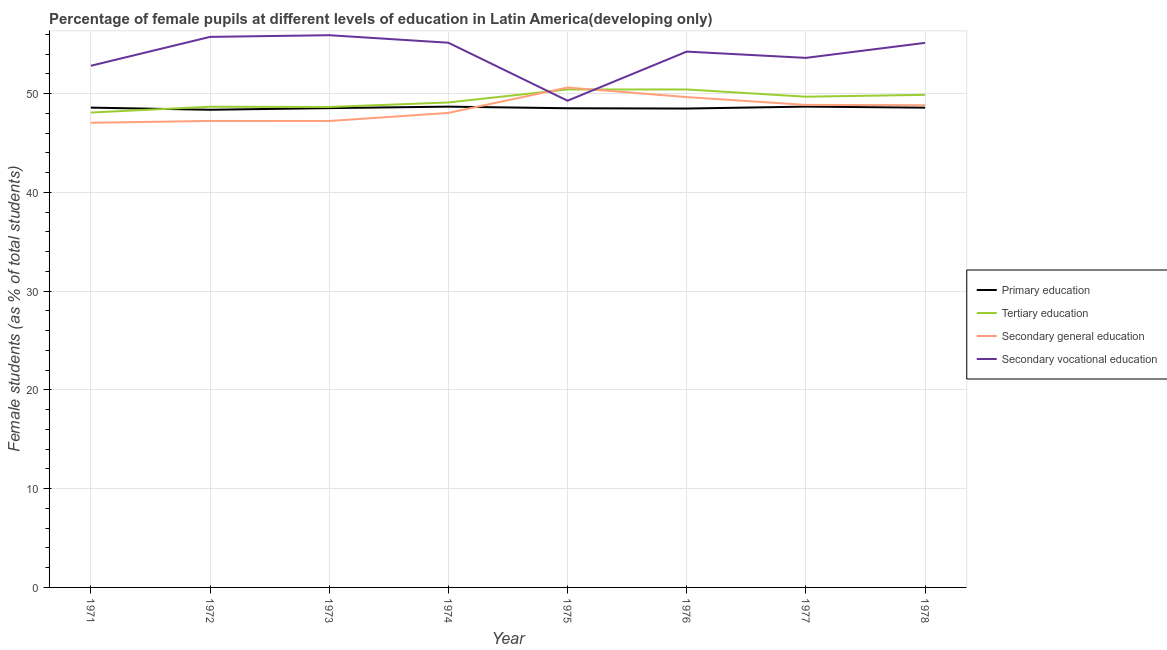Does the line corresponding to percentage of female students in secondary vocational education intersect with the line corresponding to percentage of female students in primary education?
Provide a short and direct response. No. What is the percentage of female students in secondary education in 1972?
Ensure brevity in your answer.  47.24. Across all years, what is the maximum percentage of female students in secondary vocational education?
Ensure brevity in your answer.  55.92. Across all years, what is the minimum percentage of female students in tertiary education?
Give a very brief answer. 48.09. In which year was the percentage of female students in primary education maximum?
Ensure brevity in your answer.  1977. What is the total percentage of female students in secondary education in the graph?
Keep it short and to the point. 387.55. What is the difference between the percentage of female students in secondary vocational education in 1974 and that in 1975?
Your answer should be compact. 5.87. What is the difference between the percentage of female students in secondary education in 1975 and the percentage of female students in primary education in 1973?
Keep it short and to the point. 2.08. What is the average percentage of female students in secondary vocational education per year?
Your response must be concise. 54. In the year 1977, what is the difference between the percentage of female students in tertiary education and percentage of female students in secondary education?
Your answer should be compact. 0.83. What is the ratio of the percentage of female students in secondary education in 1972 to that in 1977?
Offer a terse response. 0.97. Is the percentage of female students in primary education in 1973 less than that in 1974?
Offer a very short reply. Yes. What is the difference between the highest and the second highest percentage of female students in secondary vocational education?
Offer a very short reply. 0.17. What is the difference between the highest and the lowest percentage of female students in secondary vocational education?
Ensure brevity in your answer.  6.63. In how many years, is the percentage of female students in tertiary education greater than the average percentage of female students in tertiary education taken over all years?
Your response must be concise. 4. Is it the case that in every year, the sum of the percentage of female students in tertiary education and percentage of female students in secondary education is greater than the sum of percentage of female students in primary education and percentage of female students in secondary vocational education?
Your answer should be very brief. No. Is it the case that in every year, the sum of the percentage of female students in primary education and percentage of female students in tertiary education is greater than the percentage of female students in secondary education?
Provide a succinct answer. Yes. Is the percentage of female students in secondary education strictly greater than the percentage of female students in tertiary education over the years?
Offer a terse response. No. Is the percentage of female students in secondary education strictly less than the percentage of female students in tertiary education over the years?
Make the answer very short. No. How many lines are there?
Make the answer very short. 4. What is the difference between two consecutive major ticks on the Y-axis?
Provide a succinct answer. 10. Are the values on the major ticks of Y-axis written in scientific E-notation?
Your answer should be very brief. No. Does the graph contain any zero values?
Your answer should be compact. No. How many legend labels are there?
Keep it short and to the point. 4. What is the title of the graph?
Provide a short and direct response. Percentage of female pupils at different levels of education in Latin America(developing only). Does "European Union" appear as one of the legend labels in the graph?
Make the answer very short. No. What is the label or title of the Y-axis?
Offer a very short reply. Female students (as % of total students). What is the Female students (as % of total students) of Primary education in 1971?
Keep it short and to the point. 48.59. What is the Female students (as % of total students) in Tertiary education in 1971?
Provide a succinct answer. 48.09. What is the Female students (as % of total students) in Secondary general education in 1971?
Offer a very short reply. 47.05. What is the Female students (as % of total students) in Secondary vocational education in 1971?
Your answer should be compact. 52.83. What is the Female students (as % of total students) in Primary education in 1972?
Offer a very short reply. 48.37. What is the Female students (as % of total students) of Tertiary education in 1972?
Provide a short and direct response. 48.68. What is the Female students (as % of total students) in Secondary general education in 1972?
Give a very brief answer. 47.24. What is the Female students (as % of total students) in Secondary vocational education in 1972?
Your answer should be very brief. 55.75. What is the Female students (as % of total students) of Primary education in 1973?
Make the answer very short. 48.54. What is the Female students (as % of total students) of Tertiary education in 1973?
Make the answer very short. 48.65. What is the Female students (as % of total students) of Secondary general education in 1973?
Give a very brief answer. 47.23. What is the Female students (as % of total students) in Secondary vocational education in 1973?
Provide a short and direct response. 55.92. What is the Female students (as % of total students) in Primary education in 1974?
Offer a terse response. 48.69. What is the Female students (as % of total students) in Tertiary education in 1974?
Keep it short and to the point. 49.11. What is the Female students (as % of total students) of Secondary general education in 1974?
Your answer should be very brief. 48.05. What is the Female students (as % of total students) of Secondary vocational education in 1974?
Provide a succinct answer. 55.16. What is the Female students (as % of total students) in Primary education in 1975?
Provide a succinct answer. 48.52. What is the Female students (as % of total students) of Tertiary education in 1975?
Provide a short and direct response. 50.43. What is the Female students (as % of total students) in Secondary general education in 1975?
Your answer should be compact. 50.62. What is the Female students (as % of total students) in Secondary vocational education in 1975?
Offer a very short reply. 49.29. What is the Female students (as % of total students) of Primary education in 1976?
Your answer should be very brief. 48.49. What is the Female students (as % of total students) in Tertiary education in 1976?
Provide a succinct answer. 50.43. What is the Female students (as % of total students) in Secondary general education in 1976?
Keep it short and to the point. 49.66. What is the Female students (as % of total students) of Secondary vocational education in 1976?
Give a very brief answer. 54.26. What is the Female students (as % of total students) of Primary education in 1977?
Ensure brevity in your answer.  48.69. What is the Female students (as % of total students) in Tertiary education in 1977?
Offer a terse response. 49.69. What is the Female students (as % of total students) in Secondary general education in 1977?
Provide a succinct answer. 48.86. What is the Female students (as % of total students) of Secondary vocational education in 1977?
Give a very brief answer. 53.63. What is the Female students (as % of total students) of Primary education in 1978?
Provide a succinct answer. 48.59. What is the Female students (as % of total students) of Tertiary education in 1978?
Your answer should be compact. 49.88. What is the Female students (as % of total students) in Secondary general education in 1978?
Offer a terse response. 48.83. What is the Female students (as % of total students) of Secondary vocational education in 1978?
Offer a very short reply. 55.15. Across all years, what is the maximum Female students (as % of total students) of Primary education?
Your response must be concise. 48.69. Across all years, what is the maximum Female students (as % of total students) in Tertiary education?
Give a very brief answer. 50.43. Across all years, what is the maximum Female students (as % of total students) of Secondary general education?
Keep it short and to the point. 50.62. Across all years, what is the maximum Female students (as % of total students) of Secondary vocational education?
Give a very brief answer. 55.92. Across all years, what is the minimum Female students (as % of total students) in Primary education?
Keep it short and to the point. 48.37. Across all years, what is the minimum Female students (as % of total students) of Tertiary education?
Make the answer very short. 48.09. Across all years, what is the minimum Female students (as % of total students) of Secondary general education?
Your response must be concise. 47.05. Across all years, what is the minimum Female students (as % of total students) in Secondary vocational education?
Your answer should be very brief. 49.29. What is the total Female students (as % of total students) in Primary education in the graph?
Keep it short and to the point. 388.48. What is the total Female students (as % of total students) in Tertiary education in the graph?
Your response must be concise. 394.96. What is the total Female students (as % of total students) in Secondary general education in the graph?
Keep it short and to the point. 387.55. What is the total Female students (as % of total students) of Secondary vocational education in the graph?
Offer a terse response. 431.98. What is the difference between the Female students (as % of total students) in Primary education in 1971 and that in 1972?
Your answer should be compact. 0.22. What is the difference between the Female students (as % of total students) of Tertiary education in 1971 and that in 1972?
Offer a terse response. -0.59. What is the difference between the Female students (as % of total students) of Secondary general education in 1971 and that in 1972?
Make the answer very short. -0.19. What is the difference between the Female students (as % of total students) in Secondary vocational education in 1971 and that in 1972?
Make the answer very short. -2.93. What is the difference between the Female students (as % of total students) in Primary education in 1971 and that in 1973?
Provide a succinct answer. 0.05. What is the difference between the Female students (as % of total students) of Tertiary education in 1971 and that in 1973?
Your response must be concise. -0.56. What is the difference between the Female students (as % of total students) of Secondary general education in 1971 and that in 1973?
Give a very brief answer. -0.18. What is the difference between the Female students (as % of total students) of Secondary vocational education in 1971 and that in 1973?
Offer a terse response. -3.1. What is the difference between the Female students (as % of total students) of Primary education in 1971 and that in 1974?
Make the answer very short. -0.1. What is the difference between the Female students (as % of total students) of Tertiary education in 1971 and that in 1974?
Keep it short and to the point. -1.02. What is the difference between the Female students (as % of total students) of Secondary general education in 1971 and that in 1974?
Your answer should be compact. -1. What is the difference between the Female students (as % of total students) of Secondary vocational education in 1971 and that in 1974?
Provide a succinct answer. -2.33. What is the difference between the Female students (as % of total students) of Primary education in 1971 and that in 1975?
Ensure brevity in your answer.  0.06. What is the difference between the Female students (as % of total students) of Tertiary education in 1971 and that in 1975?
Keep it short and to the point. -2.34. What is the difference between the Female students (as % of total students) of Secondary general education in 1971 and that in 1975?
Your answer should be compact. -3.57. What is the difference between the Female students (as % of total students) of Secondary vocational education in 1971 and that in 1975?
Keep it short and to the point. 3.54. What is the difference between the Female students (as % of total students) in Primary education in 1971 and that in 1976?
Keep it short and to the point. 0.09. What is the difference between the Female students (as % of total students) of Tertiary education in 1971 and that in 1976?
Your answer should be very brief. -2.34. What is the difference between the Female students (as % of total students) in Secondary general education in 1971 and that in 1976?
Offer a terse response. -2.6. What is the difference between the Female students (as % of total students) of Secondary vocational education in 1971 and that in 1976?
Provide a short and direct response. -1.43. What is the difference between the Female students (as % of total students) of Primary education in 1971 and that in 1977?
Provide a short and direct response. -0.1. What is the difference between the Female students (as % of total students) in Tertiary education in 1971 and that in 1977?
Make the answer very short. -1.6. What is the difference between the Female students (as % of total students) of Secondary general education in 1971 and that in 1977?
Make the answer very short. -1.81. What is the difference between the Female students (as % of total students) of Secondary vocational education in 1971 and that in 1977?
Offer a very short reply. -0.8. What is the difference between the Female students (as % of total students) in Primary education in 1971 and that in 1978?
Your answer should be very brief. 0. What is the difference between the Female students (as % of total students) in Tertiary education in 1971 and that in 1978?
Ensure brevity in your answer.  -1.8. What is the difference between the Female students (as % of total students) of Secondary general education in 1971 and that in 1978?
Provide a succinct answer. -1.78. What is the difference between the Female students (as % of total students) in Secondary vocational education in 1971 and that in 1978?
Your response must be concise. -2.32. What is the difference between the Female students (as % of total students) in Primary education in 1972 and that in 1973?
Offer a very short reply. -0.17. What is the difference between the Female students (as % of total students) of Tertiary education in 1972 and that in 1973?
Offer a terse response. 0.03. What is the difference between the Female students (as % of total students) of Secondary general education in 1972 and that in 1973?
Give a very brief answer. 0.01. What is the difference between the Female students (as % of total students) of Secondary vocational education in 1972 and that in 1973?
Provide a short and direct response. -0.17. What is the difference between the Female students (as % of total students) of Primary education in 1972 and that in 1974?
Give a very brief answer. -0.32. What is the difference between the Female students (as % of total students) in Tertiary education in 1972 and that in 1974?
Ensure brevity in your answer.  -0.43. What is the difference between the Female students (as % of total students) in Secondary general education in 1972 and that in 1974?
Keep it short and to the point. -0.81. What is the difference between the Female students (as % of total students) of Secondary vocational education in 1972 and that in 1974?
Give a very brief answer. 0.59. What is the difference between the Female students (as % of total students) of Primary education in 1972 and that in 1975?
Keep it short and to the point. -0.15. What is the difference between the Female students (as % of total students) in Tertiary education in 1972 and that in 1975?
Make the answer very short. -1.75. What is the difference between the Female students (as % of total students) in Secondary general education in 1972 and that in 1975?
Offer a very short reply. -3.38. What is the difference between the Female students (as % of total students) of Secondary vocational education in 1972 and that in 1975?
Your answer should be very brief. 6.46. What is the difference between the Female students (as % of total students) in Primary education in 1972 and that in 1976?
Ensure brevity in your answer.  -0.12. What is the difference between the Female students (as % of total students) in Tertiary education in 1972 and that in 1976?
Provide a succinct answer. -1.75. What is the difference between the Female students (as % of total students) of Secondary general education in 1972 and that in 1976?
Your answer should be compact. -2.42. What is the difference between the Female students (as % of total students) in Secondary vocational education in 1972 and that in 1976?
Your answer should be compact. 1.49. What is the difference between the Female students (as % of total students) in Primary education in 1972 and that in 1977?
Ensure brevity in your answer.  -0.32. What is the difference between the Female students (as % of total students) of Tertiary education in 1972 and that in 1977?
Offer a terse response. -1.01. What is the difference between the Female students (as % of total students) in Secondary general education in 1972 and that in 1977?
Keep it short and to the point. -1.62. What is the difference between the Female students (as % of total students) in Secondary vocational education in 1972 and that in 1977?
Your response must be concise. 2.12. What is the difference between the Female students (as % of total students) of Primary education in 1972 and that in 1978?
Your answer should be compact. -0.21. What is the difference between the Female students (as % of total students) in Tertiary education in 1972 and that in 1978?
Give a very brief answer. -1.21. What is the difference between the Female students (as % of total students) of Secondary general education in 1972 and that in 1978?
Your answer should be compact. -1.59. What is the difference between the Female students (as % of total students) of Secondary vocational education in 1972 and that in 1978?
Your response must be concise. 0.61. What is the difference between the Female students (as % of total students) in Primary education in 1973 and that in 1974?
Offer a very short reply. -0.15. What is the difference between the Female students (as % of total students) of Tertiary education in 1973 and that in 1974?
Offer a very short reply. -0.46. What is the difference between the Female students (as % of total students) in Secondary general education in 1973 and that in 1974?
Your answer should be very brief. -0.82. What is the difference between the Female students (as % of total students) of Secondary vocational education in 1973 and that in 1974?
Make the answer very short. 0.76. What is the difference between the Female students (as % of total students) in Primary education in 1973 and that in 1975?
Your response must be concise. 0.01. What is the difference between the Female students (as % of total students) in Tertiary education in 1973 and that in 1975?
Ensure brevity in your answer.  -1.78. What is the difference between the Female students (as % of total students) of Secondary general education in 1973 and that in 1975?
Make the answer very short. -3.39. What is the difference between the Female students (as % of total students) of Secondary vocational education in 1973 and that in 1975?
Give a very brief answer. 6.63. What is the difference between the Female students (as % of total students) of Primary education in 1973 and that in 1976?
Your answer should be compact. 0.04. What is the difference between the Female students (as % of total students) in Tertiary education in 1973 and that in 1976?
Your answer should be compact. -1.78. What is the difference between the Female students (as % of total students) of Secondary general education in 1973 and that in 1976?
Offer a very short reply. -2.42. What is the difference between the Female students (as % of total students) in Secondary vocational education in 1973 and that in 1976?
Ensure brevity in your answer.  1.66. What is the difference between the Female students (as % of total students) in Primary education in 1973 and that in 1977?
Give a very brief answer. -0.15. What is the difference between the Female students (as % of total students) in Tertiary education in 1973 and that in 1977?
Keep it short and to the point. -1.04. What is the difference between the Female students (as % of total students) in Secondary general education in 1973 and that in 1977?
Keep it short and to the point. -1.63. What is the difference between the Female students (as % of total students) in Secondary vocational education in 1973 and that in 1977?
Provide a short and direct response. 2.3. What is the difference between the Female students (as % of total students) in Primary education in 1973 and that in 1978?
Keep it short and to the point. -0.05. What is the difference between the Female students (as % of total students) in Tertiary education in 1973 and that in 1978?
Your response must be concise. -1.23. What is the difference between the Female students (as % of total students) in Secondary general education in 1973 and that in 1978?
Offer a very short reply. -1.59. What is the difference between the Female students (as % of total students) in Secondary vocational education in 1973 and that in 1978?
Ensure brevity in your answer.  0.78. What is the difference between the Female students (as % of total students) of Primary education in 1974 and that in 1975?
Your response must be concise. 0.16. What is the difference between the Female students (as % of total students) of Tertiary education in 1974 and that in 1975?
Your answer should be very brief. -1.32. What is the difference between the Female students (as % of total students) of Secondary general education in 1974 and that in 1975?
Your answer should be very brief. -2.57. What is the difference between the Female students (as % of total students) in Secondary vocational education in 1974 and that in 1975?
Make the answer very short. 5.87. What is the difference between the Female students (as % of total students) of Primary education in 1974 and that in 1976?
Make the answer very short. 0.19. What is the difference between the Female students (as % of total students) in Tertiary education in 1974 and that in 1976?
Offer a terse response. -1.32. What is the difference between the Female students (as % of total students) of Secondary general education in 1974 and that in 1976?
Keep it short and to the point. -1.6. What is the difference between the Female students (as % of total students) in Secondary vocational education in 1974 and that in 1976?
Make the answer very short. 0.9. What is the difference between the Female students (as % of total students) in Primary education in 1974 and that in 1977?
Your answer should be compact. -0. What is the difference between the Female students (as % of total students) in Tertiary education in 1974 and that in 1977?
Make the answer very short. -0.58. What is the difference between the Female students (as % of total students) in Secondary general education in 1974 and that in 1977?
Offer a very short reply. -0.81. What is the difference between the Female students (as % of total students) of Secondary vocational education in 1974 and that in 1977?
Offer a very short reply. 1.53. What is the difference between the Female students (as % of total students) of Primary education in 1974 and that in 1978?
Ensure brevity in your answer.  0.1. What is the difference between the Female students (as % of total students) of Tertiary education in 1974 and that in 1978?
Offer a very short reply. -0.77. What is the difference between the Female students (as % of total students) in Secondary general education in 1974 and that in 1978?
Provide a succinct answer. -0.78. What is the difference between the Female students (as % of total students) in Secondary vocational education in 1974 and that in 1978?
Provide a short and direct response. 0.01. What is the difference between the Female students (as % of total students) of Primary education in 1975 and that in 1976?
Your response must be concise. 0.03. What is the difference between the Female students (as % of total students) of Tertiary education in 1975 and that in 1976?
Your response must be concise. 0. What is the difference between the Female students (as % of total students) of Secondary general education in 1975 and that in 1976?
Keep it short and to the point. 0.97. What is the difference between the Female students (as % of total students) in Secondary vocational education in 1975 and that in 1976?
Provide a short and direct response. -4.97. What is the difference between the Female students (as % of total students) of Primary education in 1975 and that in 1977?
Your response must be concise. -0.17. What is the difference between the Female students (as % of total students) in Tertiary education in 1975 and that in 1977?
Your response must be concise. 0.73. What is the difference between the Female students (as % of total students) in Secondary general education in 1975 and that in 1977?
Make the answer very short. 1.76. What is the difference between the Female students (as % of total students) in Secondary vocational education in 1975 and that in 1977?
Offer a terse response. -4.34. What is the difference between the Female students (as % of total students) of Primary education in 1975 and that in 1978?
Provide a short and direct response. -0.06. What is the difference between the Female students (as % of total students) of Tertiary education in 1975 and that in 1978?
Make the answer very short. 0.54. What is the difference between the Female students (as % of total students) in Secondary general education in 1975 and that in 1978?
Ensure brevity in your answer.  1.79. What is the difference between the Female students (as % of total students) in Secondary vocational education in 1975 and that in 1978?
Offer a terse response. -5.86. What is the difference between the Female students (as % of total students) of Primary education in 1976 and that in 1977?
Offer a very short reply. -0.2. What is the difference between the Female students (as % of total students) in Tertiary education in 1976 and that in 1977?
Offer a terse response. 0.73. What is the difference between the Female students (as % of total students) in Secondary general education in 1976 and that in 1977?
Provide a succinct answer. 0.79. What is the difference between the Female students (as % of total students) of Secondary vocational education in 1976 and that in 1977?
Ensure brevity in your answer.  0.63. What is the difference between the Female students (as % of total students) of Primary education in 1976 and that in 1978?
Provide a short and direct response. -0.09. What is the difference between the Female students (as % of total students) in Tertiary education in 1976 and that in 1978?
Your response must be concise. 0.54. What is the difference between the Female students (as % of total students) in Secondary general education in 1976 and that in 1978?
Your response must be concise. 0.83. What is the difference between the Female students (as % of total students) of Secondary vocational education in 1976 and that in 1978?
Your answer should be compact. -0.89. What is the difference between the Female students (as % of total students) of Primary education in 1977 and that in 1978?
Your answer should be compact. 0.1. What is the difference between the Female students (as % of total students) in Tertiary education in 1977 and that in 1978?
Provide a short and direct response. -0.19. What is the difference between the Female students (as % of total students) of Secondary general education in 1977 and that in 1978?
Your response must be concise. 0.04. What is the difference between the Female students (as % of total students) of Secondary vocational education in 1977 and that in 1978?
Provide a short and direct response. -1.52. What is the difference between the Female students (as % of total students) of Primary education in 1971 and the Female students (as % of total students) of Tertiary education in 1972?
Make the answer very short. -0.09. What is the difference between the Female students (as % of total students) in Primary education in 1971 and the Female students (as % of total students) in Secondary general education in 1972?
Offer a very short reply. 1.35. What is the difference between the Female students (as % of total students) in Primary education in 1971 and the Female students (as % of total students) in Secondary vocational education in 1972?
Provide a short and direct response. -7.16. What is the difference between the Female students (as % of total students) in Tertiary education in 1971 and the Female students (as % of total students) in Secondary general education in 1972?
Provide a succinct answer. 0.85. What is the difference between the Female students (as % of total students) of Tertiary education in 1971 and the Female students (as % of total students) of Secondary vocational education in 1972?
Offer a very short reply. -7.66. What is the difference between the Female students (as % of total students) of Secondary general education in 1971 and the Female students (as % of total students) of Secondary vocational education in 1972?
Keep it short and to the point. -8.7. What is the difference between the Female students (as % of total students) in Primary education in 1971 and the Female students (as % of total students) in Tertiary education in 1973?
Keep it short and to the point. -0.06. What is the difference between the Female students (as % of total students) of Primary education in 1971 and the Female students (as % of total students) of Secondary general education in 1973?
Give a very brief answer. 1.35. What is the difference between the Female students (as % of total students) in Primary education in 1971 and the Female students (as % of total students) in Secondary vocational education in 1973?
Your response must be concise. -7.33. What is the difference between the Female students (as % of total students) of Tertiary education in 1971 and the Female students (as % of total students) of Secondary general education in 1973?
Your answer should be compact. 0.86. What is the difference between the Female students (as % of total students) in Tertiary education in 1971 and the Female students (as % of total students) in Secondary vocational education in 1973?
Give a very brief answer. -7.83. What is the difference between the Female students (as % of total students) of Secondary general education in 1971 and the Female students (as % of total students) of Secondary vocational education in 1973?
Make the answer very short. -8.87. What is the difference between the Female students (as % of total students) of Primary education in 1971 and the Female students (as % of total students) of Tertiary education in 1974?
Ensure brevity in your answer.  -0.52. What is the difference between the Female students (as % of total students) in Primary education in 1971 and the Female students (as % of total students) in Secondary general education in 1974?
Your answer should be very brief. 0.54. What is the difference between the Female students (as % of total students) of Primary education in 1971 and the Female students (as % of total students) of Secondary vocational education in 1974?
Your response must be concise. -6.57. What is the difference between the Female students (as % of total students) of Tertiary education in 1971 and the Female students (as % of total students) of Secondary general education in 1974?
Give a very brief answer. 0.04. What is the difference between the Female students (as % of total students) of Tertiary education in 1971 and the Female students (as % of total students) of Secondary vocational education in 1974?
Provide a short and direct response. -7.07. What is the difference between the Female students (as % of total students) in Secondary general education in 1971 and the Female students (as % of total students) in Secondary vocational education in 1974?
Your response must be concise. -8.11. What is the difference between the Female students (as % of total students) in Primary education in 1971 and the Female students (as % of total students) in Tertiary education in 1975?
Your answer should be compact. -1.84. What is the difference between the Female students (as % of total students) in Primary education in 1971 and the Female students (as % of total students) in Secondary general education in 1975?
Provide a succinct answer. -2.03. What is the difference between the Female students (as % of total students) of Primary education in 1971 and the Female students (as % of total students) of Secondary vocational education in 1975?
Your answer should be very brief. -0.7. What is the difference between the Female students (as % of total students) of Tertiary education in 1971 and the Female students (as % of total students) of Secondary general education in 1975?
Provide a succinct answer. -2.53. What is the difference between the Female students (as % of total students) in Tertiary education in 1971 and the Female students (as % of total students) in Secondary vocational education in 1975?
Give a very brief answer. -1.2. What is the difference between the Female students (as % of total students) in Secondary general education in 1971 and the Female students (as % of total students) in Secondary vocational education in 1975?
Offer a terse response. -2.24. What is the difference between the Female students (as % of total students) in Primary education in 1971 and the Female students (as % of total students) in Tertiary education in 1976?
Provide a short and direct response. -1.84. What is the difference between the Female students (as % of total students) of Primary education in 1971 and the Female students (as % of total students) of Secondary general education in 1976?
Your response must be concise. -1.07. What is the difference between the Female students (as % of total students) of Primary education in 1971 and the Female students (as % of total students) of Secondary vocational education in 1976?
Your answer should be compact. -5.67. What is the difference between the Female students (as % of total students) of Tertiary education in 1971 and the Female students (as % of total students) of Secondary general education in 1976?
Give a very brief answer. -1.57. What is the difference between the Female students (as % of total students) in Tertiary education in 1971 and the Female students (as % of total students) in Secondary vocational education in 1976?
Give a very brief answer. -6.17. What is the difference between the Female students (as % of total students) in Secondary general education in 1971 and the Female students (as % of total students) in Secondary vocational education in 1976?
Make the answer very short. -7.21. What is the difference between the Female students (as % of total students) in Primary education in 1971 and the Female students (as % of total students) in Tertiary education in 1977?
Keep it short and to the point. -1.11. What is the difference between the Female students (as % of total students) in Primary education in 1971 and the Female students (as % of total students) in Secondary general education in 1977?
Provide a short and direct response. -0.28. What is the difference between the Female students (as % of total students) in Primary education in 1971 and the Female students (as % of total students) in Secondary vocational education in 1977?
Give a very brief answer. -5.04. What is the difference between the Female students (as % of total students) of Tertiary education in 1971 and the Female students (as % of total students) of Secondary general education in 1977?
Make the answer very short. -0.77. What is the difference between the Female students (as % of total students) in Tertiary education in 1971 and the Female students (as % of total students) in Secondary vocational education in 1977?
Offer a terse response. -5.54. What is the difference between the Female students (as % of total students) of Secondary general education in 1971 and the Female students (as % of total students) of Secondary vocational education in 1977?
Your answer should be very brief. -6.57. What is the difference between the Female students (as % of total students) in Primary education in 1971 and the Female students (as % of total students) in Tertiary education in 1978?
Provide a short and direct response. -1.3. What is the difference between the Female students (as % of total students) in Primary education in 1971 and the Female students (as % of total students) in Secondary general education in 1978?
Offer a terse response. -0.24. What is the difference between the Female students (as % of total students) in Primary education in 1971 and the Female students (as % of total students) in Secondary vocational education in 1978?
Your answer should be compact. -6.56. What is the difference between the Female students (as % of total students) of Tertiary education in 1971 and the Female students (as % of total students) of Secondary general education in 1978?
Provide a succinct answer. -0.74. What is the difference between the Female students (as % of total students) in Tertiary education in 1971 and the Female students (as % of total students) in Secondary vocational education in 1978?
Give a very brief answer. -7.06. What is the difference between the Female students (as % of total students) of Secondary general education in 1971 and the Female students (as % of total students) of Secondary vocational education in 1978?
Your answer should be very brief. -8.09. What is the difference between the Female students (as % of total students) in Primary education in 1972 and the Female students (as % of total students) in Tertiary education in 1973?
Ensure brevity in your answer.  -0.28. What is the difference between the Female students (as % of total students) of Primary education in 1972 and the Female students (as % of total students) of Secondary general education in 1973?
Ensure brevity in your answer.  1.14. What is the difference between the Female students (as % of total students) of Primary education in 1972 and the Female students (as % of total students) of Secondary vocational education in 1973?
Make the answer very short. -7.55. What is the difference between the Female students (as % of total students) of Tertiary education in 1972 and the Female students (as % of total students) of Secondary general education in 1973?
Offer a very short reply. 1.45. What is the difference between the Female students (as % of total students) of Tertiary education in 1972 and the Female students (as % of total students) of Secondary vocational education in 1973?
Your answer should be compact. -7.24. What is the difference between the Female students (as % of total students) in Secondary general education in 1972 and the Female students (as % of total students) in Secondary vocational education in 1973?
Your response must be concise. -8.68. What is the difference between the Female students (as % of total students) of Primary education in 1972 and the Female students (as % of total students) of Tertiary education in 1974?
Give a very brief answer. -0.74. What is the difference between the Female students (as % of total students) of Primary education in 1972 and the Female students (as % of total students) of Secondary general education in 1974?
Keep it short and to the point. 0.32. What is the difference between the Female students (as % of total students) in Primary education in 1972 and the Female students (as % of total students) in Secondary vocational education in 1974?
Ensure brevity in your answer.  -6.79. What is the difference between the Female students (as % of total students) in Tertiary education in 1972 and the Female students (as % of total students) in Secondary general education in 1974?
Your answer should be compact. 0.63. What is the difference between the Female students (as % of total students) in Tertiary education in 1972 and the Female students (as % of total students) in Secondary vocational education in 1974?
Provide a short and direct response. -6.48. What is the difference between the Female students (as % of total students) in Secondary general education in 1972 and the Female students (as % of total students) in Secondary vocational education in 1974?
Offer a very short reply. -7.92. What is the difference between the Female students (as % of total students) in Primary education in 1972 and the Female students (as % of total students) in Tertiary education in 1975?
Make the answer very short. -2.06. What is the difference between the Female students (as % of total students) in Primary education in 1972 and the Female students (as % of total students) in Secondary general education in 1975?
Your response must be concise. -2.25. What is the difference between the Female students (as % of total students) in Primary education in 1972 and the Female students (as % of total students) in Secondary vocational education in 1975?
Provide a succinct answer. -0.92. What is the difference between the Female students (as % of total students) in Tertiary education in 1972 and the Female students (as % of total students) in Secondary general education in 1975?
Your answer should be very brief. -1.94. What is the difference between the Female students (as % of total students) in Tertiary education in 1972 and the Female students (as % of total students) in Secondary vocational education in 1975?
Offer a very short reply. -0.61. What is the difference between the Female students (as % of total students) in Secondary general education in 1972 and the Female students (as % of total students) in Secondary vocational education in 1975?
Make the answer very short. -2.05. What is the difference between the Female students (as % of total students) of Primary education in 1972 and the Female students (as % of total students) of Tertiary education in 1976?
Offer a terse response. -2.06. What is the difference between the Female students (as % of total students) of Primary education in 1972 and the Female students (as % of total students) of Secondary general education in 1976?
Your response must be concise. -1.28. What is the difference between the Female students (as % of total students) of Primary education in 1972 and the Female students (as % of total students) of Secondary vocational education in 1976?
Your answer should be very brief. -5.89. What is the difference between the Female students (as % of total students) in Tertiary education in 1972 and the Female students (as % of total students) in Secondary general education in 1976?
Your answer should be very brief. -0.98. What is the difference between the Female students (as % of total students) of Tertiary education in 1972 and the Female students (as % of total students) of Secondary vocational education in 1976?
Provide a short and direct response. -5.58. What is the difference between the Female students (as % of total students) in Secondary general education in 1972 and the Female students (as % of total students) in Secondary vocational education in 1976?
Your answer should be compact. -7.02. What is the difference between the Female students (as % of total students) of Primary education in 1972 and the Female students (as % of total students) of Tertiary education in 1977?
Keep it short and to the point. -1.32. What is the difference between the Female students (as % of total students) in Primary education in 1972 and the Female students (as % of total students) in Secondary general education in 1977?
Provide a succinct answer. -0.49. What is the difference between the Female students (as % of total students) in Primary education in 1972 and the Female students (as % of total students) in Secondary vocational education in 1977?
Keep it short and to the point. -5.26. What is the difference between the Female students (as % of total students) in Tertiary education in 1972 and the Female students (as % of total students) in Secondary general education in 1977?
Your response must be concise. -0.18. What is the difference between the Female students (as % of total students) in Tertiary education in 1972 and the Female students (as % of total students) in Secondary vocational education in 1977?
Ensure brevity in your answer.  -4.95. What is the difference between the Female students (as % of total students) in Secondary general education in 1972 and the Female students (as % of total students) in Secondary vocational education in 1977?
Your answer should be compact. -6.39. What is the difference between the Female students (as % of total students) of Primary education in 1972 and the Female students (as % of total students) of Tertiary education in 1978?
Ensure brevity in your answer.  -1.51. What is the difference between the Female students (as % of total students) in Primary education in 1972 and the Female students (as % of total students) in Secondary general education in 1978?
Ensure brevity in your answer.  -0.46. What is the difference between the Female students (as % of total students) in Primary education in 1972 and the Female students (as % of total students) in Secondary vocational education in 1978?
Your response must be concise. -6.77. What is the difference between the Female students (as % of total students) in Tertiary education in 1972 and the Female students (as % of total students) in Secondary general education in 1978?
Your answer should be compact. -0.15. What is the difference between the Female students (as % of total students) of Tertiary education in 1972 and the Female students (as % of total students) of Secondary vocational education in 1978?
Provide a short and direct response. -6.47. What is the difference between the Female students (as % of total students) in Secondary general education in 1972 and the Female students (as % of total students) in Secondary vocational education in 1978?
Your response must be concise. -7.91. What is the difference between the Female students (as % of total students) in Primary education in 1973 and the Female students (as % of total students) in Tertiary education in 1974?
Offer a terse response. -0.57. What is the difference between the Female students (as % of total students) in Primary education in 1973 and the Female students (as % of total students) in Secondary general education in 1974?
Make the answer very short. 0.49. What is the difference between the Female students (as % of total students) in Primary education in 1973 and the Female students (as % of total students) in Secondary vocational education in 1974?
Offer a terse response. -6.62. What is the difference between the Female students (as % of total students) in Tertiary education in 1973 and the Female students (as % of total students) in Secondary general education in 1974?
Offer a terse response. 0.6. What is the difference between the Female students (as % of total students) of Tertiary education in 1973 and the Female students (as % of total students) of Secondary vocational education in 1974?
Your answer should be very brief. -6.51. What is the difference between the Female students (as % of total students) in Secondary general education in 1973 and the Female students (as % of total students) in Secondary vocational education in 1974?
Offer a terse response. -7.93. What is the difference between the Female students (as % of total students) of Primary education in 1973 and the Female students (as % of total students) of Tertiary education in 1975?
Your answer should be very brief. -1.89. What is the difference between the Female students (as % of total students) of Primary education in 1973 and the Female students (as % of total students) of Secondary general education in 1975?
Offer a terse response. -2.08. What is the difference between the Female students (as % of total students) of Primary education in 1973 and the Female students (as % of total students) of Secondary vocational education in 1975?
Your response must be concise. -0.75. What is the difference between the Female students (as % of total students) in Tertiary education in 1973 and the Female students (as % of total students) in Secondary general education in 1975?
Keep it short and to the point. -1.97. What is the difference between the Female students (as % of total students) in Tertiary education in 1973 and the Female students (as % of total students) in Secondary vocational education in 1975?
Offer a terse response. -0.64. What is the difference between the Female students (as % of total students) in Secondary general education in 1973 and the Female students (as % of total students) in Secondary vocational education in 1975?
Provide a short and direct response. -2.05. What is the difference between the Female students (as % of total students) of Primary education in 1973 and the Female students (as % of total students) of Tertiary education in 1976?
Your answer should be compact. -1.89. What is the difference between the Female students (as % of total students) of Primary education in 1973 and the Female students (as % of total students) of Secondary general education in 1976?
Ensure brevity in your answer.  -1.12. What is the difference between the Female students (as % of total students) of Primary education in 1973 and the Female students (as % of total students) of Secondary vocational education in 1976?
Offer a very short reply. -5.72. What is the difference between the Female students (as % of total students) of Tertiary education in 1973 and the Female students (as % of total students) of Secondary general education in 1976?
Your answer should be very brief. -1. What is the difference between the Female students (as % of total students) in Tertiary education in 1973 and the Female students (as % of total students) in Secondary vocational education in 1976?
Provide a succinct answer. -5.61. What is the difference between the Female students (as % of total students) of Secondary general education in 1973 and the Female students (as % of total students) of Secondary vocational education in 1976?
Give a very brief answer. -7.03. What is the difference between the Female students (as % of total students) in Primary education in 1973 and the Female students (as % of total students) in Tertiary education in 1977?
Keep it short and to the point. -1.16. What is the difference between the Female students (as % of total students) in Primary education in 1973 and the Female students (as % of total students) in Secondary general education in 1977?
Ensure brevity in your answer.  -0.33. What is the difference between the Female students (as % of total students) in Primary education in 1973 and the Female students (as % of total students) in Secondary vocational education in 1977?
Give a very brief answer. -5.09. What is the difference between the Female students (as % of total students) of Tertiary education in 1973 and the Female students (as % of total students) of Secondary general education in 1977?
Ensure brevity in your answer.  -0.21. What is the difference between the Female students (as % of total students) of Tertiary education in 1973 and the Female students (as % of total students) of Secondary vocational education in 1977?
Provide a succinct answer. -4.98. What is the difference between the Female students (as % of total students) of Secondary general education in 1973 and the Female students (as % of total students) of Secondary vocational education in 1977?
Give a very brief answer. -6.39. What is the difference between the Female students (as % of total students) in Primary education in 1973 and the Female students (as % of total students) in Tertiary education in 1978?
Offer a very short reply. -1.35. What is the difference between the Female students (as % of total students) of Primary education in 1973 and the Female students (as % of total students) of Secondary general education in 1978?
Keep it short and to the point. -0.29. What is the difference between the Female students (as % of total students) in Primary education in 1973 and the Female students (as % of total students) in Secondary vocational education in 1978?
Your answer should be very brief. -6.61. What is the difference between the Female students (as % of total students) in Tertiary education in 1973 and the Female students (as % of total students) in Secondary general education in 1978?
Give a very brief answer. -0.18. What is the difference between the Female students (as % of total students) in Tertiary education in 1973 and the Female students (as % of total students) in Secondary vocational education in 1978?
Your response must be concise. -6.5. What is the difference between the Female students (as % of total students) in Secondary general education in 1973 and the Female students (as % of total students) in Secondary vocational education in 1978?
Give a very brief answer. -7.91. What is the difference between the Female students (as % of total students) in Primary education in 1974 and the Female students (as % of total students) in Tertiary education in 1975?
Provide a succinct answer. -1.74. What is the difference between the Female students (as % of total students) of Primary education in 1974 and the Female students (as % of total students) of Secondary general education in 1975?
Keep it short and to the point. -1.94. What is the difference between the Female students (as % of total students) of Primary education in 1974 and the Female students (as % of total students) of Secondary vocational education in 1975?
Ensure brevity in your answer.  -0.6. What is the difference between the Female students (as % of total students) of Tertiary education in 1974 and the Female students (as % of total students) of Secondary general education in 1975?
Ensure brevity in your answer.  -1.51. What is the difference between the Female students (as % of total students) in Tertiary education in 1974 and the Female students (as % of total students) in Secondary vocational education in 1975?
Your response must be concise. -0.18. What is the difference between the Female students (as % of total students) in Secondary general education in 1974 and the Female students (as % of total students) in Secondary vocational education in 1975?
Your answer should be compact. -1.24. What is the difference between the Female students (as % of total students) of Primary education in 1974 and the Female students (as % of total students) of Tertiary education in 1976?
Make the answer very short. -1.74. What is the difference between the Female students (as % of total students) of Primary education in 1974 and the Female students (as % of total students) of Secondary general education in 1976?
Make the answer very short. -0.97. What is the difference between the Female students (as % of total students) of Primary education in 1974 and the Female students (as % of total students) of Secondary vocational education in 1976?
Your response must be concise. -5.57. What is the difference between the Female students (as % of total students) in Tertiary education in 1974 and the Female students (as % of total students) in Secondary general education in 1976?
Provide a succinct answer. -0.55. What is the difference between the Female students (as % of total students) of Tertiary education in 1974 and the Female students (as % of total students) of Secondary vocational education in 1976?
Your answer should be compact. -5.15. What is the difference between the Female students (as % of total students) of Secondary general education in 1974 and the Female students (as % of total students) of Secondary vocational education in 1976?
Provide a short and direct response. -6.21. What is the difference between the Female students (as % of total students) in Primary education in 1974 and the Female students (as % of total students) in Tertiary education in 1977?
Offer a very short reply. -1.01. What is the difference between the Female students (as % of total students) of Primary education in 1974 and the Female students (as % of total students) of Secondary general education in 1977?
Keep it short and to the point. -0.18. What is the difference between the Female students (as % of total students) in Primary education in 1974 and the Female students (as % of total students) in Secondary vocational education in 1977?
Your answer should be very brief. -4.94. What is the difference between the Female students (as % of total students) of Tertiary education in 1974 and the Female students (as % of total students) of Secondary general education in 1977?
Give a very brief answer. 0.25. What is the difference between the Female students (as % of total students) in Tertiary education in 1974 and the Female students (as % of total students) in Secondary vocational education in 1977?
Offer a very short reply. -4.52. What is the difference between the Female students (as % of total students) of Secondary general education in 1974 and the Female students (as % of total students) of Secondary vocational education in 1977?
Make the answer very short. -5.57. What is the difference between the Female students (as % of total students) of Primary education in 1974 and the Female students (as % of total students) of Tertiary education in 1978?
Offer a terse response. -1.2. What is the difference between the Female students (as % of total students) of Primary education in 1974 and the Female students (as % of total students) of Secondary general education in 1978?
Give a very brief answer. -0.14. What is the difference between the Female students (as % of total students) of Primary education in 1974 and the Female students (as % of total students) of Secondary vocational education in 1978?
Offer a very short reply. -6.46. What is the difference between the Female students (as % of total students) in Tertiary education in 1974 and the Female students (as % of total students) in Secondary general education in 1978?
Ensure brevity in your answer.  0.28. What is the difference between the Female students (as % of total students) of Tertiary education in 1974 and the Female students (as % of total students) of Secondary vocational education in 1978?
Ensure brevity in your answer.  -6.04. What is the difference between the Female students (as % of total students) of Secondary general education in 1974 and the Female students (as % of total students) of Secondary vocational education in 1978?
Ensure brevity in your answer.  -7.09. What is the difference between the Female students (as % of total students) of Primary education in 1975 and the Female students (as % of total students) of Tertiary education in 1976?
Your response must be concise. -1.9. What is the difference between the Female students (as % of total students) of Primary education in 1975 and the Female students (as % of total students) of Secondary general education in 1976?
Ensure brevity in your answer.  -1.13. What is the difference between the Female students (as % of total students) in Primary education in 1975 and the Female students (as % of total students) in Secondary vocational education in 1976?
Give a very brief answer. -5.74. What is the difference between the Female students (as % of total students) of Tertiary education in 1975 and the Female students (as % of total students) of Secondary general education in 1976?
Your response must be concise. 0.77. What is the difference between the Female students (as % of total students) of Tertiary education in 1975 and the Female students (as % of total students) of Secondary vocational education in 1976?
Keep it short and to the point. -3.83. What is the difference between the Female students (as % of total students) of Secondary general education in 1975 and the Female students (as % of total students) of Secondary vocational education in 1976?
Ensure brevity in your answer.  -3.64. What is the difference between the Female students (as % of total students) of Primary education in 1975 and the Female students (as % of total students) of Tertiary education in 1977?
Provide a succinct answer. -1.17. What is the difference between the Female students (as % of total students) of Primary education in 1975 and the Female students (as % of total students) of Secondary general education in 1977?
Offer a terse response. -0.34. What is the difference between the Female students (as % of total students) in Primary education in 1975 and the Female students (as % of total students) in Secondary vocational education in 1977?
Offer a very short reply. -5.1. What is the difference between the Female students (as % of total students) of Tertiary education in 1975 and the Female students (as % of total students) of Secondary general education in 1977?
Your answer should be compact. 1.56. What is the difference between the Female students (as % of total students) in Tertiary education in 1975 and the Female students (as % of total students) in Secondary vocational education in 1977?
Offer a very short reply. -3.2. What is the difference between the Female students (as % of total students) of Secondary general education in 1975 and the Female students (as % of total students) of Secondary vocational education in 1977?
Provide a succinct answer. -3. What is the difference between the Female students (as % of total students) in Primary education in 1975 and the Female students (as % of total students) in Tertiary education in 1978?
Make the answer very short. -1.36. What is the difference between the Female students (as % of total students) of Primary education in 1975 and the Female students (as % of total students) of Secondary general education in 1978?
Provide a short and direct response. -0.3. What is the difference between the Female students (as % of total students) in Primary education in 1975 and the Female students (as % of total students) in Secondary vocational education in 1978?
Ensure brevity in your answer.  -6.62. What is the difference between the Female students (as % of total students) in Tertiary education in 1975 and the Female students (as % of total students) in Secondary general education in 1978?
Your answer should be compact. 1.6. What is the difference between the Female students (as % of total students) of Tertiary education in 1975 and the Female students (as % of total students) of Secondary vocational education in 1978?
Offer a very short reply. -4.72. What is the difference between the Female students (as % of total students) in Secondary general education in 1975 and the Female students (as % of total students) in Secondary vocational education in 1978?
Provide a succinct answer. -4.52. What is the difference between the Female students (as % of total students) of Primary education in 1976 and the Female students (as % of total students) of Tertiary education in 1977?
Provide a short and direct response. -1.2. What is the difference between the Female students (as % of total students) of Primary education in 1976 and the Female students (as % of total students) of Secondary general education in 1977?
Keep it short and to the point. -0.37. What is the difference between the Female students (as % of total students) in Primary education in 1976 and the Female students (as % of total students) in Secondary vocational education in 1977?
Ensure brevity in your answer.  -5.13. What is the difference between the Female students (as % of total students) in Tertiary education in 1976 and the Female students (as % of total students) in Secondary general education in 1977?
Provide a succinct answer. 1.56. What is the difference between the Female students (as % of total students) in Tertiary education in 1976 and the Female students (as % of total students) in Secondary vocational education in 1977?
Offer a very short reply. -3.2. What is the difference between the Female students (as % of total students) of Secondary general education in 1976 and the Female students (as % of total students) of Secondary vocational education in 1977?
Give a very brief answer. -3.97. What is the difference between the Female students (as % of total students) of Primary education in 1976 and the Female students (as % of total students) of Tertiary education in 1978?
Keep it short and to the point. -1.39. What is the difference between the Female students (as % of total students) in Primary education in 1976 and the Female students (as % of total students) in Secondary general education in 1978?
Offer a terse response. -0.33. What is the difference between the Female students (as % of total students) of Primary education in 1976 and the Female students (as % of total students) of Secondary vocational education in 1978?
Make the answer very short. -6.65. What is the difference between the Female students (as % of total students) in Tertiary education in 1976 and the Female students (as % of total students) in Secondary general education in 1978?
Your response must be concise. 1.6. What is the difference between the Female students (as % of total students) of Tertiary education in 1976 and the Female students (as % of total students) of Secondary vocational education in 1978?
Make the answer very short. -4.72. What is the difference between the Female students (as % of total students) in Secondary general education in 1976 and the Female students (as % of total students) in Secondary vocational education in 1978?
Give a very brief answer. -5.49. What is the difference between the Female students (as % of total students) of Primary education in 1977 and the Female students (as % of total students) of Tertiary education in 1978?
Make the answer very short. -1.19. What is the difference between the Female students (as % of total students) of Primary education in 1977 and the Female students (as % of total students) of Secondary general education in 1978?
Offer a terse response. -0.14. What is the difference between the Female students (as % of total students) of Primary education in 1977 and the Female students (as % of total students) of Secondary vocational education in 1978?
Give a very brief answer. -6.46. What is the difference between the Female students (as % of total students) in Tertiary education in 1977 and the Female students (as % of total students) in Secondary general education in 1978?
Ensure brevity in your answer.  0.87. What is the difference between the Female students (as % of total students) of Tertiary education in 1977 and the Female students (as % of total students) of Secondary vocational education in 1978?
Your answer should be compact. -5.45. What is the difference between the Female students (as % of total students) in Secondary general education in 1977 and the Female students (as % of total students) in Secondary vocational education in 1978?
Ensure brevity in your answer.  -6.28. What is the average Female students (as % of total students) in Primary education per year?
Ensure brevity in your answer.  48.56. What is the average Female students (as % of total students) in Tertiary education per year?
Offer a terse response. 49.37. What is the average Female students (as % of total students) of Secondary general education per year?
Offer a very short reply. 48.44. What is the average Female students (as % of total students) in Secondary vocational education per year?
Ensure brevity in your answer.  54. In the year 1971, what is the difference between the Female students (as % of total students) of Primary education and Female students (as % of total students) of Tertiary education?
Make the answer very short. 0.5. In the year 1971, what is the difference between the Female students (as % of total students) in Primary education and Female students (as % of total students) in Secondary general education?
Your answer should be compact. 1.54. In the year 1971, what is the difference between the Female students (as % of total students) of Primary education and Female students (as % of total students) of Secondary vocational education?
Provide a succinct answer. -4.24. In the year 1971, what is the difference between the Female students (as % of total students) in Tertiary education and Female students (as % of total students) in Secondary general education?
Ensure brevity in your answer.  1.04. In the year 1971, what is the difference between the Female students (as % of total students) in Tertiary education and Female students (as % of total students) in Secondary vocational education?
Provide a succinct answer. -4.74. In the year 1971, what is the difference between the Female students (as % of total students) of Secondary general education and Female students (as % of total students) of Secondary vocational education?
Keep it short and to the point. -5.77. In the year 1972, what is the difference between the Female students (as % of total students) of Primary education and Female students (as % of total students) of Tertiary education?
Your answer should be very brief. -0.31. In the year 1972, what is the difference between the Female students (as % of total students) in Primary education and Female students (as % of total students) in Secondary general education?
Keep it short and to the point. 1.13. In the year 1972, what is the difference between the Female students (as % of total students) in Primary education and Female students (as % of total students) in Secondary vocational education?
Offer a terse response. -7.38. In the year 1972, what is the difference between the Female students (as % of total students) in Tertiary education and Female students (as % of total students) in Secondary general education?
Offer a terse response. 1.44. In the year 1972, what is the difference between the Female students (as % of total students) in Tertiary education and Female students (as % of total students) in Secondary vocational education?
Offer a very short reply. -7.07. In the year 1972, what is the difference between the Female students (as % of total students) in Secondary general education and Female students (as % of total students) in Secondary vocational education?
Keep it short and to the point. -8.51. In the year 1973, what is the difference between the Female students (as % of total students) in Primary education and Female students (as % of total students) in Tertiary education?
Provide a succinct answer. -0.11. In the year 1973, what is the difference between the Female students (as % of total students) of Primary education and Female students (as % of total students) of Secondary general education?
Provide a short and direct response. 1.3. In the year 1973, what is the difference between the Female students (as % of total students) of Primary education and Female students (as % of total students) of Secondary vocational education?
Make the answer very short. -7.38. In the year 1973, what is the difference between the Female students (as % of total students) of Tertiary education and Female students (as % of total students) of Secondary general education?
Your answer should be very brief. 1.42. In the year 1973, what is the difference between the Female students (as % of total students) of Tertiary education and Female students (as % of total students) of Secondary vocational education?
Your answer should be compact. -7.27. In the year 1973, what is the difference between the Female students (as % of total students) in Secondary general education and Female students (as % of total students) in Secondary vocational education?
Your response must be concise. -8.69. In the year 1974, what is the difference between the Female students (as % of total students) of Primary education and Female students (as % of total students) of Tertiary education?
Keep it short and to the point. -0.42. In the year 1974, what is the difference between the Female students (as % of total students) in Primary education and Female students (as % of total students) in Secondary general education?
Ensure brevity in your answer.  0.63. In the year 1974, what is the difference between the Female students (as % of total students) of Primary education and Female students (as % of total students) of Secondary vocational education?
Give a very brief answer. -6.47. In the year 1974, what is the difference between the Female students (as % of total students) in Tertiary education and Female students (as % of total students) in Secondary general education?
Ensure brevity in your answer.  1.06. In the year 1974, what is the difference between the Female students (as % of total students) of Tertiary education and Female students (as % of total students) of Secondary vocational education?
Offer a terse response. -6.05. In the year 1974, what is the difference between the Female students (as % of total students) in Secondary general education and Female students (as % of total students) in Secondary vocational education?
Offer a terse response. -7.11. In the year 1975, what is the difference between the Female students (as % of total students) in Primary education and Female students (as % of total students) in Tertiary education?
Ensure brevity in your answer.  -1.9. In the year 1975, what is the difference between the Female students (as % of total students) in Primary education and Female students (as % of total students) in Secondary general education?
Your answer should be compact. -2.1. In the year 1975, what is the difference between the Female students (as % of total students) in Primary education and Female students (as % of total students) in Secondary vocational education?
Offer a terse response. -0.76. In the year 1975, what is the difference between the Female students (as % of total students) in Tertiary education and Female students (as % of total students) in Secondary general education?
Provide a short and direct response. -0.2. In the year 1975, what is the difference between the Female students (as % of total students) of Tertiary education and Female students (as % of total students) of Secondary vocational education?
Your answer should be very brief. 1.14. In the year 1975, what is the difference between the Female students (as % of total students) in Secondary general education and Female students (as % of total students) in Secondary vocational education?
Your answer should be very brief. 1.33. In the year 1976, what is the difference between the Female students (as % of total students) in Primary education and Female students (as % of total students) in Tertiary education?
Ensure brevity in your answer.  -1.93. In the year 1976, what is the difference between the Female students (as % of total students) in Primary education and Female students (as % of total students) in Secondary general education?
Keep it short and to the point. -1.16. In the year 1976, what is the difference between the Female students (as % of total students) of Primary education and Female students (as % of total students) of Secondary vocational education?
Keep it short and to the point. -5.77. In the year 1976, what is the difference between the Female students (as % of total students) of Tertiary education and Female students (as % of total students) of Secondary general education?
Keep it short and to the point. 0.77. In the year 1976, what is the difference between the Female students (as % of total students) in Tertiary education and Female students (as % of total students) in Secondary vocational education?
Provide a succinct answer. -3.83. In the year 1976, what is the difference between the Female students (as % of total students) in Secondary general education and Female students (as % of total students) in Secondary vocational education?
Keep it short and to the point. -4.6. In the year 1977, what is the difference between the Female students (as % of total students) of Primary education and Female students (as % of total students) of Tertiary education?
Ensure brevity in your answer.  -1. In the year 1977, what is the difference between the Female students (as % of total students) of Primary education and Female students (as % of total students) of Secondary general education?
Offer a terse response. -0.17. In the year 1977, what is the difference between the Female students (as % of total students) in Primary education and Female students (as % of total students) in Secondary vocational education?
Give a very brief answer. -4.94. In the year 1977, what is the difference between the Female students (as % of total students) in Tertiary education and Female students (as % of total students) in Secondary general education?
Your answer should be compact. 0.83. In the year 1977, what is the difference between the Female students (as % of total students) of Tertiary education and Female students (as % of total students) of Secondary vocational education?
Your answer should be very brief. -3.93. In the year 1977, what is the difference between the Female students (as % of total students) of Secondary general education and Female students (as % of total students) of Secondary vocational education?
Keep it short and to the point. -4.76. In the year 1978, what is the difference between the Female students (as % of total students) in Primary education and Female students (as % of total students) in Tertiary education?
Offer a very short reply. -1.3. In the year 1978, what is the difference between the Female students (as % of total students) of Primary education and Female students (as % of total students) of Secondary general education?
Provide a succinct answer. -0.24. In the year 1978, what is the difference between the Female students (as % of total students) in Primary education and Female students (as % of total students) in Secondary vocational education?
Provide a short and direct response. -6.56. In the year 1978, what is the difference between the Female students (as % of total students) in Tertiary education and Female students (as % of total students) in Secondary general education?
Your response must be concise. 1.06. In the year 1978, what is the difference between the Female students (as % of total students) in Tertiary education and Female students (as % of total students) in Secondary vocational education?
Offer a terse response. -5.26. In the year 1978, what is the difference between the Female students (as % of total students) in Secondary general education and Female students (as % of total students) in Secondary vocational education?
Your answer should be compact. -6.32. What is the ratio of the Female students (as % of total students) of Tertiary education in 1971 to that in 1972?
Provide a succinct answer. 0.99. What is the ratio of the Female students (as % of total students) in Secondary general education in 1971 to that in 1972?
Provide a short and direct response. 1. What is the ratio of the Female students (as % of total students) in Secondary vocational education in 1971 to that in 1972?
Make the answer very short. 0.95. What is the ratio of the Female students (as % of total students) of Primary education in 1971 to that in 1973?
Provide a short and direct response. 1. What is the ratio of the Female students (as % of total students) of Tertiary education in 1971 to that in 1973?
Ensure brevity in your answer.  0.99. What is the ratio of the Female students (as % of total students) in Secondary general education in 1971 to that in 1973?
Your answer should be compact. 1. What is the ratio of the Female students (as % of total students) in Secondary vocational education in 1971 to that in 1973?
Offer a very short reply. 0.94. What is the ratio of the Female students (as % of total students) of Tertiary education in 1971 to that in 1974?
Your answer should be compact. 0.98. What is the ratio of the Female students (as % of total students) of Secondary general education in 1971 to that in 1974?
Provide a succinct answer. 0.98. What is the ratio of the Female students (as % of total students) of Secondary vocational education in 1971 to that in 1974?
Keep it short and to the point. 0.96. What is the ratio of the Female students (as % of total students) of Primary education in 1971 to that in 1975?
Your response must be concise. 1. What is the ratio of the Female students (as % of total students) of Tertiary education in 1971 to that in 1975?
Your answer should be very brief. 0.95. What is the ratio of the Female students (as % of total students) of Secondary general education in 1971 to that in 1975?
Your response must be concise. 0.93. What is the ratio of the Female students (as % of total students) in Secondary vocational education in 1971 to that in 1975?
Provide a succinct answer. 1.07. What is the ratio of the Female students (as % of total students) of Primary education in 1971 to that in 1976?
Your answer should be compact. 1. What is the ratio of the Female students (as % of total students) in Tertiary education in 1971 to that in 1976?
Keep it short and to the point. 0.95. What is the ratio of the Female students (as % of total students) in Secondary general education in 1971 to that in 1976?
Your answer should be very brief. 0.95. What is the ratio of the Female students (as % of total students) of Secondary vocational education in 1971 to that in 1976?
Provide a short and direct response. 0.97. What is the ratio of the Female students (as % of total students) in Primary education in 1971 to that in 1977?
Offer a very short reply. 1. What is the ratio of the Female students (as % of total students) of Tertiary education in 1971 to that in 1977?
Your answer should be compact. 0.97. What is the ratio of the Female students (as % of total students) of Secondary general education in 1971 to that in 1977?
Provide a succinct answer. 0.96. What is the ratio of the Female students (as % of total students) of Secondary vocational education in 1971 to that in 1977?
Your answer should be compact. 0.99. What is the ratio of the Female students (as % of total students) in Primary education in 1971 to that in 1978?
Keep it short and to the point. 1. What is the ratio of the Female students (as % of total students) of Tertiary education in 1971 to that in 1978?
Offer a terse response. 0.96. What is the ratio of the Female students (as % of total students) of Secondary general education in 1971 to that in 1978?
Ensure brevity in your answer.  0.96. What is the ratio of the Female students (as % of total students) in Secondary vocational education in 1971 to that in 1978?
Your response must be concise. 0.96. What is the ratio of the Female students (as % of total students) of Primary education in 1972 to that in 1973?
Your response must be concise. 1. What is the ratio of the Female students (as % of total students) of Tertiary education in 1972 to that in 1973?
Your answer should be compact. 1. What is the ratio of the Female students (as % of total students) of Secondary general education in 1972 to that in 1974?
Provide a short and direct response. 0.98. What is the ratio of the Female students (as % of total students) of Secondary vocational education in 1972 to that in 1974?
Ensure brevity in your answer.  1.01. What is the ratio of the Female students (as % of total students) in Primary education in 1972 to that in 1975?
Keep it short and to the point. 1. What is the ratio of the Female students (as % of total students) in Tertiary education in 1972 to that in 1975?
Your answer should be very brief. 0.97. What is the ratio of the Female students (as % of total students) of Secondary general education in 1972 to that in 1975?
Provide a succinct answer. 0.93. What is the ratio of the Female students (as % of total students) in Secondary vocational education in 1972 to that in 1975?
Offer a very short reply. 1.13. What is the ratio of the Female students (as % of total students) in Primary education in 1972 to that in 1976?
Provide a short and direct response. 1. What is the ratio of the Female students (as % of total students) of Tertiary education in 1972 to that in 1976?
Your answer should be compact. 0.97. What is the ratio of the Female students (as % of total students) in Secondary general education in 1972 to that in 1976?
Provide a succinct answer. 0.95. What is the ratio of the Female students (as % of total students) of Secondary vocational education in 1972 to that in 1976?
Provide a short and direct response. 1.03. What is the ratio of the Female students (as % of total students) in Tertiary education in 1972 to that in 1977?
Keep it short and to the point. 0.98. What is the ratio of the Female students (as % of total students) in Secondary general education in 1972 to that in 1977?
Your answer should be very brief. 0.97. What is the ratio of the Female students (as % of total students) in Secondary vocational education in 1972 to that in 1977?
Your answer should be compact. 1.04. What is the ratio of the Female students (as % of total students) in Primary education in 1972 to that in 1978?
Give a very brief answer. 1. What is the ratio of the Female students (as % of total students) in Tertiary education in 1972 to that in 1978?
Your answer should be compact. 0.98. What is the ratio of the Female students (as % of total students) of Secondary general education in 1972 to that in 1978?
Make the answer very short. 0.97. What is the ratio of the Female students (as % of total students) of Secondary vocational education in 1972 to that in 1978?
Make the answer very short. 1.01. What is the ratio of the Female students (as % of total students) in Primary education in 1973 to that in 1974?
Offer a terse response. 1. What is the ratio of the Female students (as % of total students) of Tertiary education in 1973 to that in 1974?
Make the answer very short. 0.99. What is the ratio of the Female students (as % of total students) in Secondary general education in 1973 to that in 1974?
Your response must be concise. 0.98. What is the ratio of the Female students (as % of total students) in Secondary vocational education in 1973 to that in 1974?
Make the answer very short. 1.01. What is the ratio of the Female students (as % of total students) in Primary education in 1973 to that in 1975?
Offer a very short reply. 1. What is the ratio of the Female students (as % of total students) in Tertiary education in 1973 to that in 1975?
Offer a terse response. 0.96. What is the ratio of the Female students (as % of total students) in Secondary general education in 1973 to that in 1975?
Your answer should be compact. 0.93. What is the ratio of the Female students (as % of total students) of Secondary vocational education in 1973 to that in 1975?
Ensure brevity in your answer.  1.13. What is the ratio of the Female students (as % of total students) in Primary education in 1973 to that in 1976?
Offer a very short reply. 1. What is the ratio of the Female students (as % of total students) of Tertiary education in 1973 to that in 1976?
Provide a short and direct response. 0.96. What is the ratio of the Female students (as % of total students) of Secondary general education in 1973 to that in 1976?
Provide a short and direct response. 0.95. What is the ratio of the Female students (as % of total students) of Secondary vocational education in 1973 to that in 1976?
Your answer should be very brief. 1.03. What is the ratio of the Female students (as % of total students) in Tertiary education in 1973 to that in 1977?
Your answer should be very brief. 0.98. What is the ratio of the Female students (as % of total students) of Secondary general education in 1973 to that in 1977?
Provide a short and direct response. 0.97. What is the ratio of the Female students (as % of total students) in Secondary vocational education in 1973 to that in 1977?
Your answer should be compact. 1.04. What is the ratio of the Female students (as % of total students) of Primary education in 1973 to that in 1978?
Your answer should be very brief. 1. What is the ratio of the Female students (as % of total students) of Tertiary education in 1973 to that in 1978?
Ensure brevity in your answer.  0.98. What is the ratio of the Female students (as % of total students) in Secondary general education in 1973 to that in 1978?
Make the answer very short. 0.97. What is the ratio of the Female students (as % of total students) in Secondary vocational education in 1973 to that in 1978?
Your response must be concise. 1.01. What is the ratio of the Female students (as % of total students) in Tertiary education in 1974 to that in 1975?
Offer a terse response. 0.97. What is the ratio of the Female students (as % of total students) in Secondary general education in 1974 to that in 1975?
Offer a terse response. 0.95. What is the ratio of the Female students (as % of total students) of Secondary vocational education in 1974 to that in 1975?
Make the answer very short. 1.12. What is the ratio of the Female students (as % of total students) in Primary education in 1974 to that in 1976?
Make the answer very short. 1. What is the ratio of the Female students (as % of total students) in Tertiary education in 1974 to that in 1976?
Ensure brevity in your answer.  0.97. What is the ratio of the Female students (as % of total students) in Secondary vocational education in 1974 to that in 1976?
Offer a terse response. 1.02. What is the ratio of the Female students (as % of total students) in Primary education in 1974 to that in 1977?
Offer a terse response. 1. What is the ratio of the Female students (as % of total students) of Tertiary education in 1974 to that in 1977?
Offer a terse response. 0.99. What is the ratio of the Female students (as % of total students) in Secondary general education in 1974 to that in 1977?
Provide a short and direct response. 0.98. What is the ratio of the Female students (as % of total students) in Secondary vocational education in 1974 to that in 1977?
Your response must be concise. 1.03. What is the ratio of the Female students (as % of total students) of Primary education in 1974 to that in 1978?
Your answer should be very brief. 1. What is the ratio of the Female students (as % of total students) in Tertiary education in 1974 to that in 1978?
Keep it short and to the point. 0.98. What is the ratio of the Female students (as % of total students) of Secondary general education in 1974 to that in 1978?
Make the answer very short. 0.98. What is the ratio of the Female students (as % of total students) of Primary education in 1975 to that in 1976?
Provide a succinct answer. 1. What is the ratio of the Female students (as % of total students) of Secondary general education in 1975 to that in 1976?
Provide a succinct answer. 1.02. What is the ratio of the Female students (as % of total students) in Secondary vocational education in 1975 to that in 1976?
Make the answer very short. 0.91. What is the ratio of the Female students (as % of total students) of Primary education in 1975 to that in 1977?
Make the answer very short. 1. What is the ratio of the Female students (as % of total students) in Tertiary education in 1975 to that in 1977?
Give a very brief answer. 1.01. What is the ratio of the Female students (as % of total students) of Secondary general education in 1975 to that in 1977?
Give a very brief answer. 1.04. What is the ratio of the Female students (as % of total students) in Secondary vocational education in 1975 to that in 1977?
Your answer should be very brief. 0.92. What is the ratio of the Female students (as % of total students) in Tertiary education in 1975 to that in 1978?
Your answer should be compact. 1.01. What is the ratio of the Female students (as % of total students) in Secondary general education in 1975 to that in 1978?
Your response must be concise. 1.04. What is the ratio of the Female students (as % of total students) in Secondary vocational education in 1975 to that in 1978?
Make the answer very short. 0.89. What is the ratio of the Female students (as % of total students) of Primary education in 1976 to that in 1977?
Make the answer very short. 1. What is the ratio of the Female students (as % of total students) of Tertiary education in 1976 to that in 1977?
Keep it short and to the point. 1.01. What is the ratio of the Female students (as % of total students) of Secondary general education in 1976 to that in 1977?
Your answer should be compact. 1.02. What is the ratio of the Female students (as % of total students) in Secondary vocational education in 1976 to that in 1977?
Keep it short and to the point. 1.01. What is the ratio of the Female students (as % of total students) of Tertiary education in 1976 to that in 1978?
Give a very brief answer. 1.01. What is the ratio of the Female students (as % of total students) of Secondary vocational education in 1976 to that in 1978?
Your answer should be very brief. 0.98. What is the ratio of the Female students (as % of total students) of Tertiary education in 1977 to that in 1978?
Keep it short and to the point. 1. What is the ratio of the Female students (as % of total students) of Secondary general education in 1977 to that in 1978?
Keep it short and to the point. 1. What is the ratio of the Female students (as % of total students) in Secondary vocational education in 1977 to that in 1978?
Give a very brief answer. 0.97. What is the difference between the highest and the second highest Female students (as % of total students) in Primary education?
Provide a succinct answer. 0. What is the difference between the highest and the second highest Female students (as % of total students) in Tertiary education?
Your response must be concise. 0. What is the difference between the highest and the second highest Female students (as % of total students) in Secondary general education?
Provide a short and direct response. 0.97. What is the difference between the highest and the second highest Female students (as % of total students) in Secondary vocational education?
Provide a short and direct response. 0.17. What is the difference between the highest and the lowest Female students (as % of total students) in Primary education?
Your response must be concise. 0.32. What is the difference between the highest and the lowest Female students (as % of total students) of Tertiary education?
Provide a succinct answer. 2.34. What is the difference between the highest and the lowest Female students (as % of total students) in Secondary general education?
Offer a very short reply. 3.57. What is the difference between the highest and the lowest Female students (as % of total students) in Secondary vocational education?
Offer a very short reply. 6.63. 